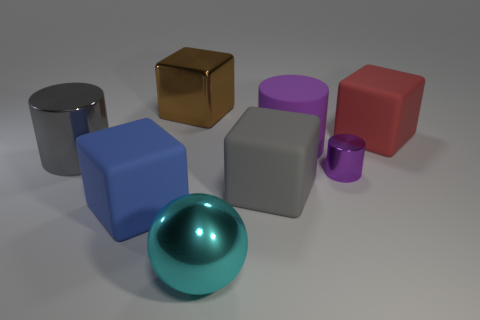Subtract all big cylinders. How many cylinders are left? 1 Add 1 tiny purple metal cylinders. How many objects exist? 9 Subtract all yellow blocks. Subtract all brown cylinders. How many blocks are left? 4 Subtract all balls. How many objects are left? 7 Add 3 big blue rubber cubes. How many big blue rubber cubes exist? 4 Subtract 0 brown cylinders. How many objects are left? 8 Subtract all tiny red things. Subtract all red rubber cubes. How many objects are left? 7 Add 8 big cyan things. How many big cyan things are left? 9 